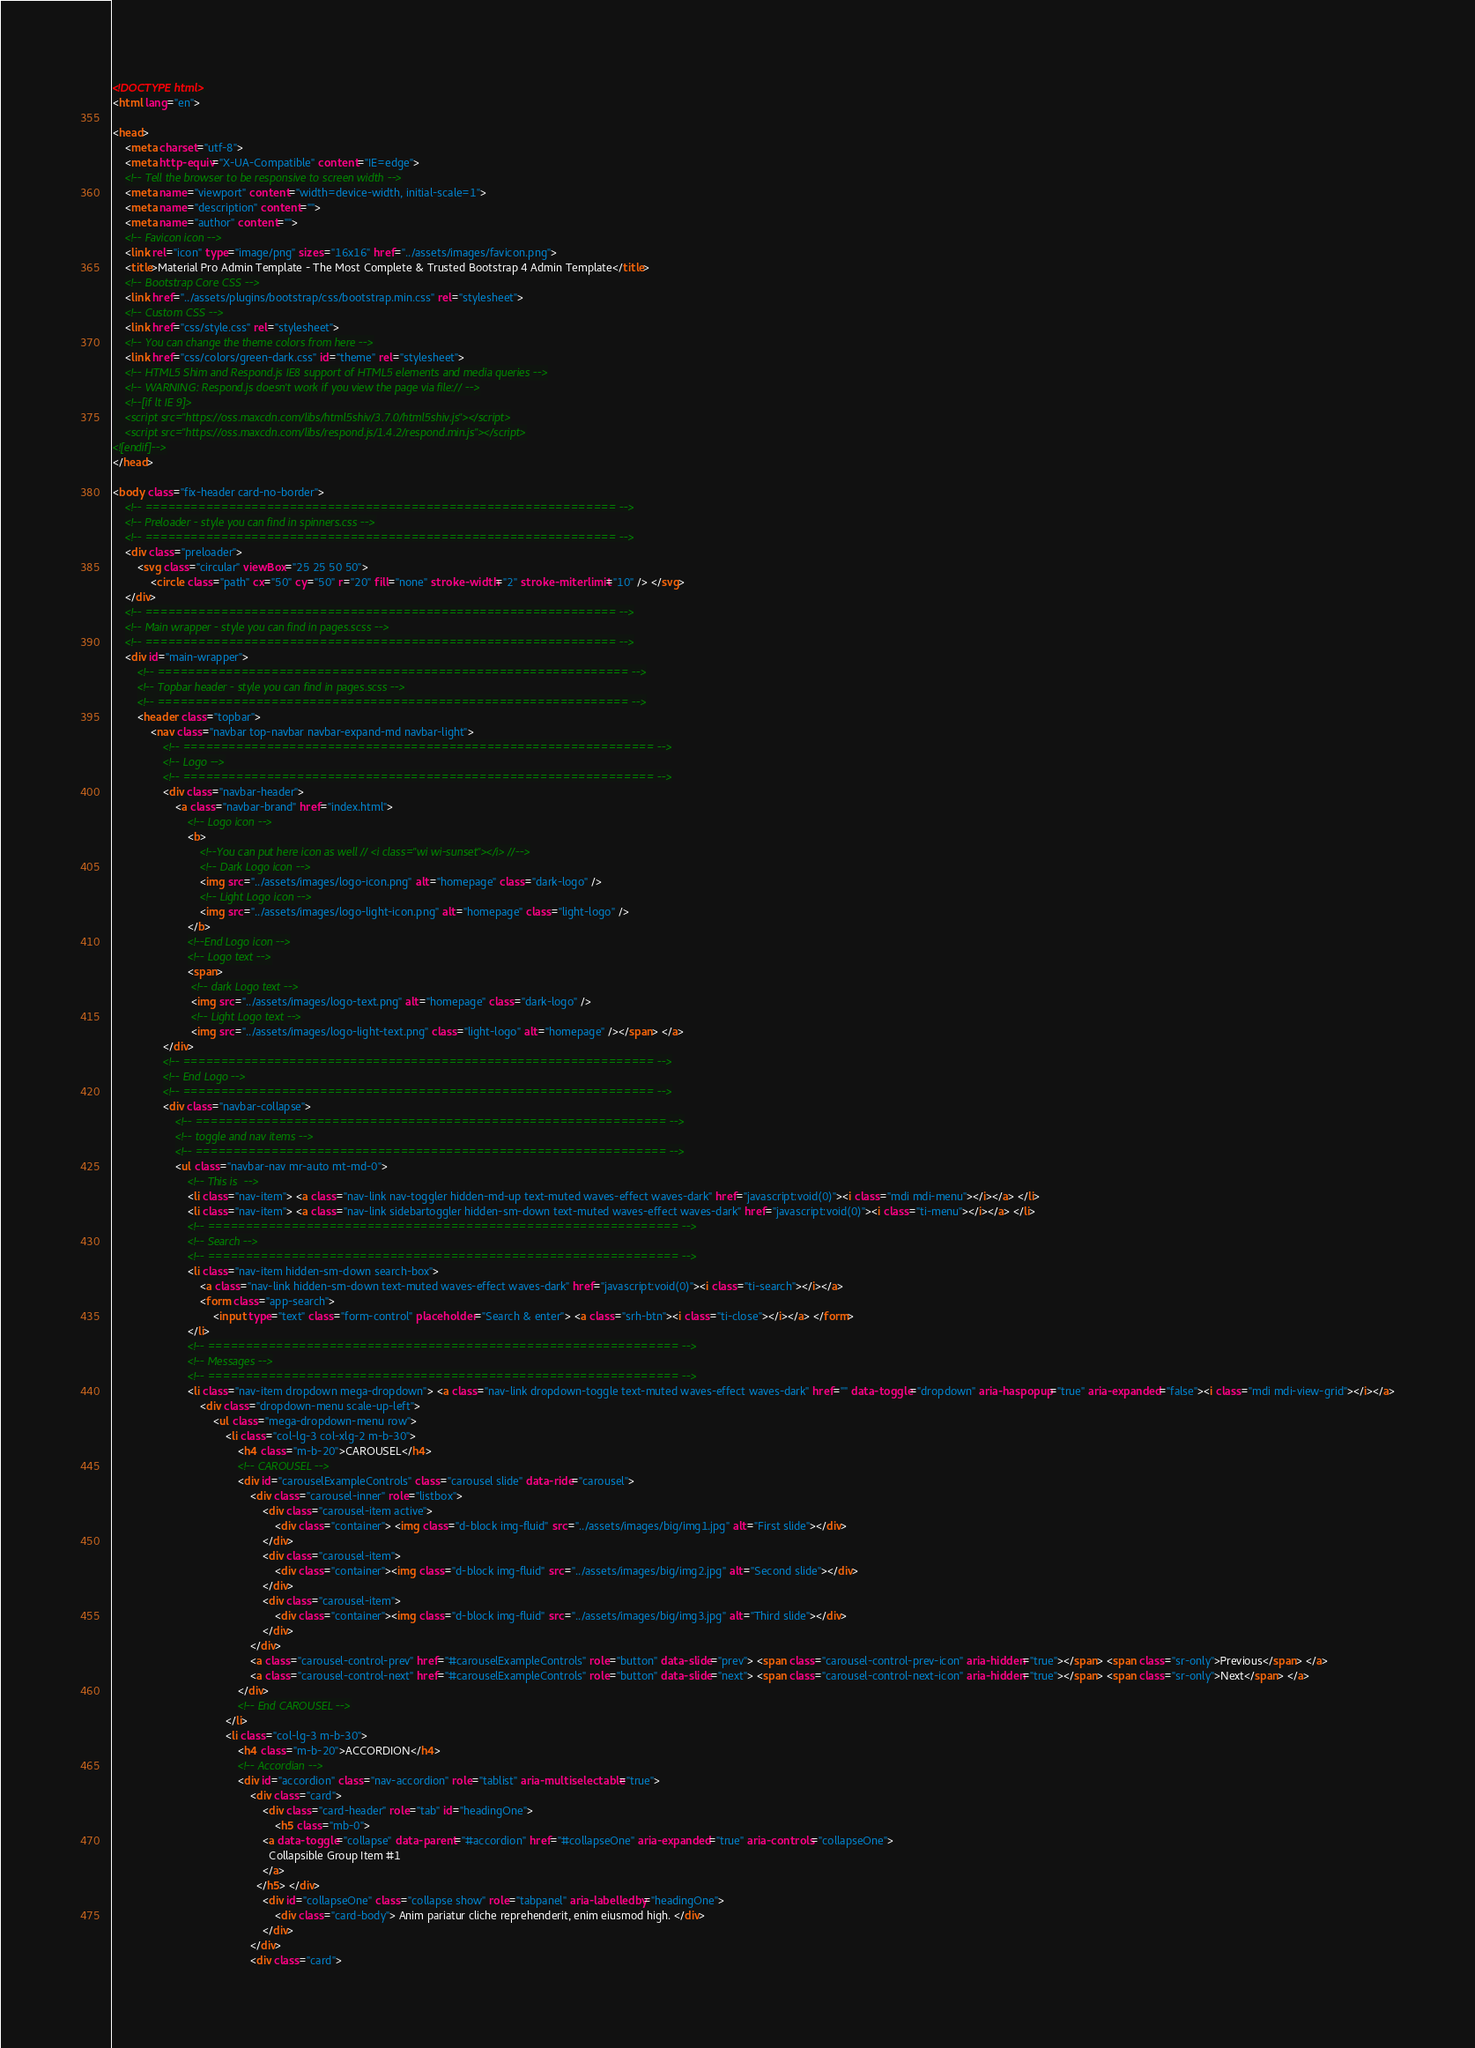Convert code to text. <code><loc_0><loc_0><loc_500><loc_500><_HTML_><!DOCTYPE html>
<html lang="en">

<head>
    <meta charset="utf-8">
    <meta http-equiv="X-UA-Compatible" content="IE=edge">
    <!-- Tell the browser to be responsive to screen width -->
    <meta name="viewport" content="width=device-width, initial-scale=1">
    <meta name="description" content="">
    <meta name="author" content="">
    <!-- Favicon icon -->
    <link rel="icon" type="image/png" sizes="16x16" href="../assets/images/favicon.png">
    <title>Material Pro Admin Template - The Most Complete & Trusted Bootstrap 4 Admin Template</title>
    <!-- Bootstrap Core CSS -->
    <link href="../assets/plugins/bootstrap/css/bootstrap.min.css" rel="stylesheet">
    <!-- Custom CSS -->
    <link href="css/style.css" rel="stylesheet">
    <!-- You can change the theme colors from here -->
    <link href="css/colors/green-dark.css" id="theme" rel="stylesheet">
    <!-- HTML5 Shim and Respond.js IE8 support of HTML5 elements and media queries -->
    <!-- WARNING: Respond.js doesn't work if you view the page via file:// -->
    <!--[if lt IE 9]>
    <script src="https://oss.maxcdn.com/libs/html5shiv/3.7.0/html5shiv.js"></script>
    <script src="https://oss.maxcdn.com/libs/respond.js/1.4.2/respond.min.js"></script>
<![endif]-->
</head>

<body class="fix-header card-no-border">
    <!-- ============================================================== -->
    <!-- Preloader - style you can find in spinners.css -->
    <!-- ============================================================== -->
    <div class="preloader">
        <svg class="circular" viewBox="25 25 50 50">
            <circle class="path" cx="50" cy="50" r="20" fill="none" stroke-width="2" stroke-miterlimit="10" /> </svg>
    </div>
    <!-- ============================================================== -->
    <!-- Main wrapper - style you can find in pages.scss -->
    <!-- ============================================================== -->
    <div id="main-wrapper">
        <!-- ============================================================== -->
        <!-- Topbar header - style you can find in pages.scss -->
        <!-- ============================================================== -->
        <header class="topbar">
            <nav class="navbar top-navbar navbar-expand-md navbar-light">
                <!-- ============================================================== -->
                <!-- Logo -->
                <!-- ============================================================== -->
                <div class="navbar-header">
                    <a class="navbar-brand" href="index.html">
                        <!-- Logo icon -->
                        <b>
                            <!--You can put here icon as well // <i class="wi wi-sunset"></i> //-->
                            <!-- Dark Logo icon -->
                            <img src="../assets/images/logo-icon.png" alt="homepage" class="dark-logo" />
                            <!-- Light Logo icon -->
                            <img src="../assets/images/logo-light-icon.png" alt="homepage" class="light-logo" />
                        </b>
                        <!--End Logo icon -->
                        <!-- Logo text -->
                        <span>
                         <!-- dark Logo text -->
                         <img src="../assets/images/logo-text.png" alt="homepage" class="dark-logo" />
                         <!-- Light Logo text -->    
                         <img src="../assets/images/logo-light-text.png" class="light-logo" alt="homepage" /></span> </a>
                </div>
                <!-- ============================================================== -->
                <!-- End Logo -->
                <!-- ============================================================== -->
                <div class="navbar-collapse">
                    <!-- ============================================================== -->
                    <!-- toggle and nav items -->
                    <!-- ============================================================== -->
                    <ul class="navbar-nav mr-auto mt-md-0">
                        <!-- This is  -->
                        <li class="nav-item"> <a class="nav-link nav-toggler hidden-md-up text-muted waves-effect waves-dark" href="javascript:void(0)"><i class="mdi mdi-menu"></i></a> </li>
                        <li class="nav-item"> <a class="nav-link sidebartoggler hidden-sm-down text-muted waves-effect waves-dark" href="javascript:void(0)"><i class="ti-menu"></i></a> </li>
                        <!-- ============================================================== -->
                        <!-- Search -->
                        <!-- ============================================================== -->
                        <li class="nav-item hidden-sm-down search-box">
                            <a class="nav-link hidden-sm-down text-muted waves-effect waves-dark" href="javascript:void(0)"><i class="ti-search"></i></a>
                            <form class="app-search">
                                <input type="text" class="form-control" placeholder="Search & enter"> <a class="srh-btn"><i class="ti-close"></i></a> </form>
                        </li>
                        <!-- ============================================================== -->
                        <!-- Messages -->
                        <!-- ============================================================== -->
                        <li class="nav-item dropdown mega-dropdown"> <a class="nav-link dropdown-toggle text-muted waves-effect waves-dark" href="" data-toggle="dropdown" aria-haspopup="true" aria-expanded="false"><i class="mdi mdi-view-grid"></i></a>
                            <div class="dropdown-menu scale-up-left">
                                <ul class="mega-dropdown-menu row">
                                    <li class="col-lg-3 col-xlg-2 m-b-30">
                                        <h4 class="m-b-20">CAROUSEL</h4>
                                        <!-- CAROUSEL -->
                                        <div id="carouselExampleControls" class="carousel slide" data-ride="carousel">
                                            <div class="carousel-inner" role="listbox">
                                                <div class="carousel-item active">
                                                    <div class="container"> <img class="d-block img-fluid" src="../assets/images/big/img1.jpg" alt="First slide"></div>
                                                </div>
                                                <div class="carousel-item">
                                                    <div class="container"><img class="d-block img-fluid" src="../assets/images/big/img2.jpg" alt="Second slide"></div>
                                                </div>
                                                <div class="carousel-item">
                                                    <div class="container"><img class="d-block img-fluid" src="../assets/images/big/img3.jpg" alt="Third slide"></div>
                                                </div>
                                            </div>
                                            <a class="carousel-control-prev" href="#carouselExampleControls" role="button" data-slide="prev"> <span class="carousel-control-prev-icon" aria-hidden="true"></span> <span class="sr-only">Previous</span> </a>
                                            <a class="carousel-control-next" href="#carouselExampleControls" role="button" data-slide="next"> <span class="carousel-control-next-icon" aria-hidden="true"></span> <span class="sr-only">Next</span> </a>
                                        </div>
                                        <!-- End CAROUSEL -->
                                    </li>
                                    <li class="col-lg-3 m-b-30">
                                        <h4 class="m-b-20">ACCORDION</h4>
                                        <!-- Accordian -->
                                        <div id="accordion" class="nav-accordion" role="tablist" aria-multiselectable="true">
                                            <div class="card">
                                                <div class="card-header" role="tab" id="headingOne">
                                                    <h5 class="mb-0">
                                                <a data-toggle="collapse" data-parent="#accordion" href="#collapseOne" aria-expanded="true" aria-controls="collapseOne">
                                                  Collapsible Group Item #1
                                                </a>
                                              </h5> </div>
                                                <div id="collapseOne" class="collapse show" role="tabpanel" aria-labelledby="headingOne">
                                                    <div class="card-body"> Anim pariatur cliche reprehenderit, enim eiusmod high. </div>
                                                </div>
                                            </div>
                                            <div class="card"></code> 